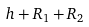<formula> <loc_0><loc_0><loc_500><loc_500>h + R _ { 1 } + R _ { 2 }</formula> 